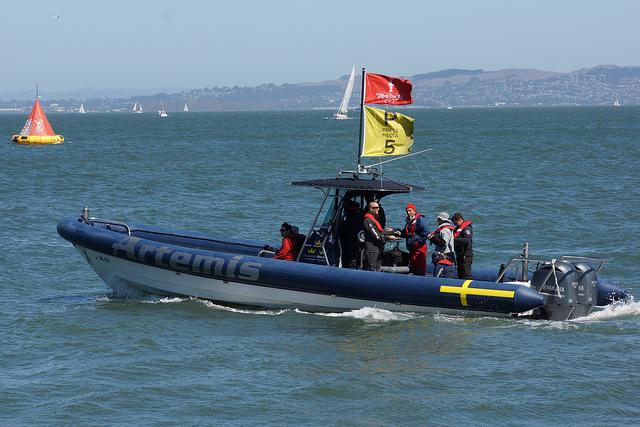Is the water frozen?
Keep it brief. No. How many boats are visible?
Quick response, please. 2. How many people are in the picture?
Answer briefly. 5. 